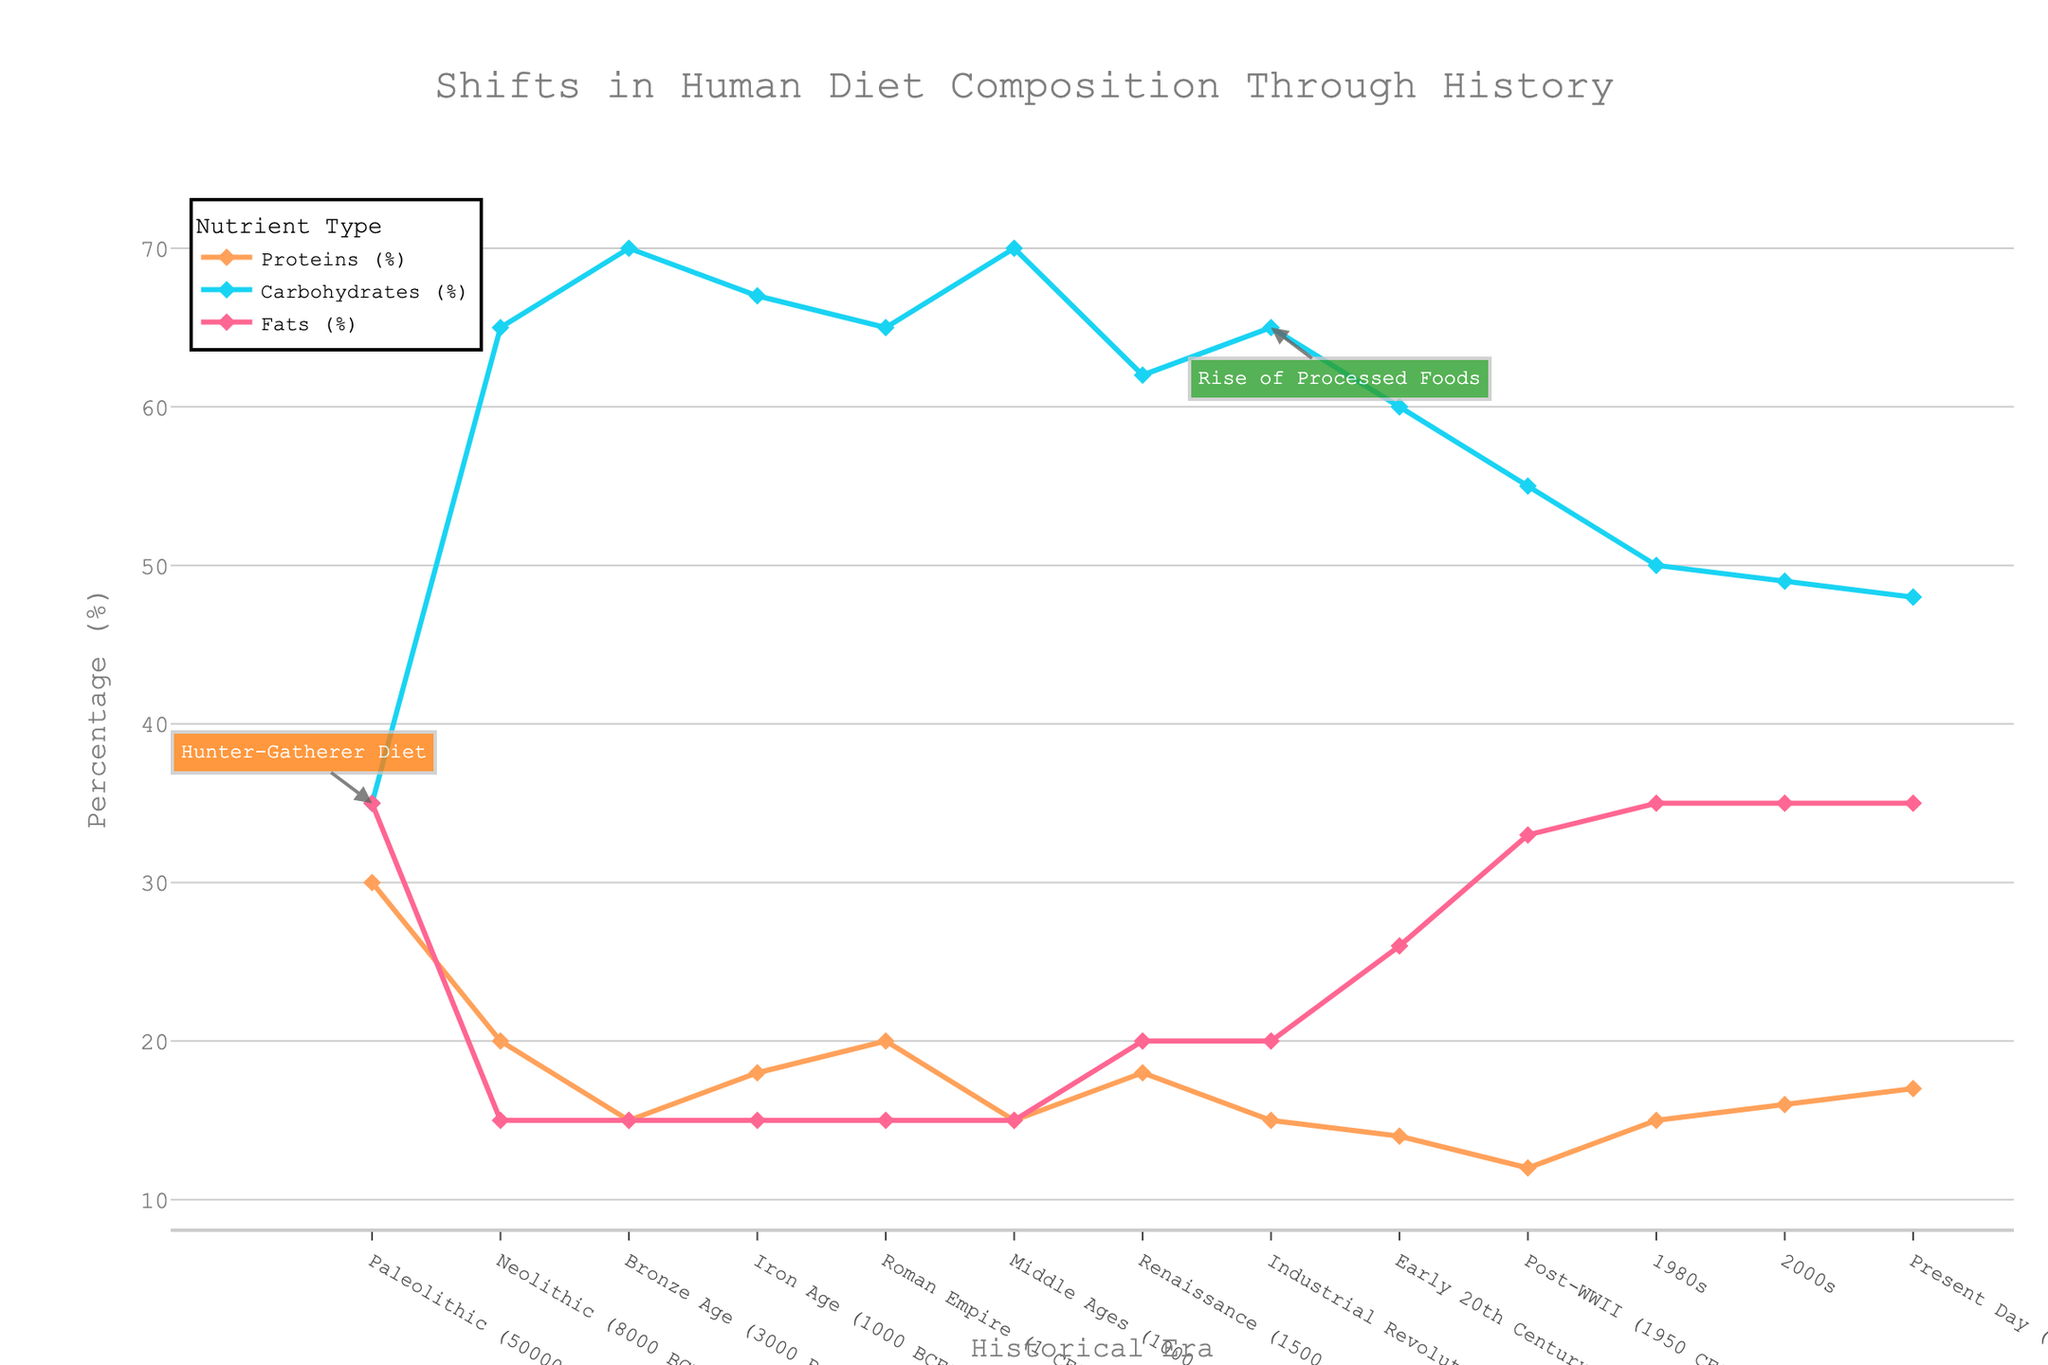What historical era shows the highest percentage of carbohydrate consumption? Observing the figure, the era with the peak carbohydrate consumption, marked by the topmost line segment for carbohydrates, occurs during the Bronze Age (3000 BCE), where the percentage reaches 70%.
Answer: Bronze Age Between which two consecutive eras is there the biggest decrease in protein consumption? By examining the line for proteins, the largest drop appears between the Paleolithic (50000 BCE) and Neolithic (8000 BCE), where the percentage falls from 30% to 20%, indicating a 10% decrease.
Answer: Paleolithic to Neolithic How has the percentage of fats in the diet changed from the Paleolithic to the Industrial Revolution? Looking closely at the fat percentage line, the value stays flat at 35% during the Paleolithic and drops to 20% by the Industrial Revolution (1800 CE). This indicates a decrease from 35% to 20%.
Answer: Decreased by 15% What is the average percentage of protein consumption from the Renaissance up to the Present Day? We determine the average by summing the protein percentages from the Renaissance (1500 CE) to Present Day (2023), which are 18%, 15%, 14%, 12%, 15%, 16%, and 17%, and then divide by the number of eras, resulting in (18 + 15 + 14 + 12 + 15 + 16 + 17) / 7 = 15.29%.
Answer: 15.29% Which nutrient type saw a shift in percentage values during multiple eras but ended up the same in the present day as in the Paleolithic era? Observing the start and endpoints of the lines, fats have varied across eras but end at 35% in the Present Day, the same percentage they had in the Paleolithic era.
Answer: Fats How does the nutrient composition during the Neolithic era compare with the Middle Ages? Comparing the lines for both eras, the Neolithic shows 20% proteins, 65% carbohydrates, and 15% fats, while the Middle Ages display 15% proteins, 70% carbohydrates, and 15% fats. This means that carbohydrates increased by 5%, while protein decreased by 5%, and fats remained the same.
Answer: Carbohydrates increased, proteins decreased, fats remained the same What can be inferred about the human diet transition from the Middle Ages to the Renaissance based on the chart? Looking at the lines, between the Middle Ages and the Renaissance, proteins increased from 15% to 18%, carbohydrates decreased from 70% to 62%, and fats increased from 15% to 20%. This implies a move towards a more balanced diet with slightly higher protein and fats.
Answer: Increase in protein and fats, decrease in carbohydrates In which era does the annotation "Rise of Processed Foods" appear, and what is its significance in terms of nutrient composition? The annotation "Rise of Processed Foods" appears during the Industrial Revolution (1800 CE). This signifies a notable rise in carbohydrate consumption to 65%, maintaining protein at 15%, and a slight increase in fats to 20%, aligning with the era when processed foods started to become more common.
Answer: Industrial Revolution, increased carbohydrate and fat consumption How did dietary fat percentage change from the Early 20th Century to the Post-WWII era? Referring to the figure, the fats line rises from 26% in the Early 20th Century (1900 CE) to 33% in the Post-WWII era (1950 CE), showcasing an increase in fat consumption.
Answer: Increased by 7% 